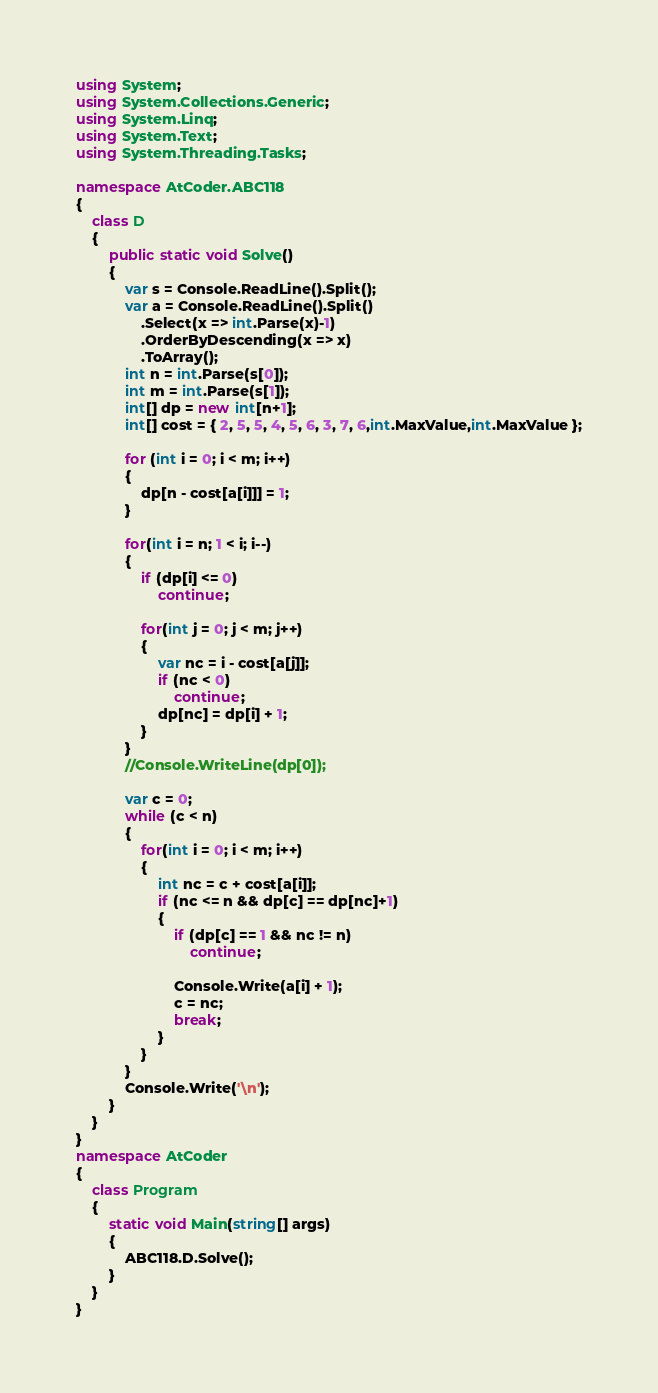<code> <loc_0><loc_0><loc_500><loc_500><_C#_>using System;
using System.Collections.Generic;
using System.Linq;
using System.Text;
using System.Threading.Tasks;

namespace AtCoder.ABC118
{
    class D
    {
        public static void Solve()
        {
            var s = Console.ReadLine().Split();
            var a = Console.ReadLine().Split()
                .Select(x => int.Parse(x)-1)
                .OrderByDescending(x => x)
                .ToArray();
            int n = int.Parse(s[0]);
            int m = int.Parse(s[1]);
            int[] dp = new int[n+1];
            int[] cost = { 2, 5, 5, 4, 5, 6, 3, 7, 6,int.MaxValue,int.MaxValue };

            for (int i = 0; i < m; i++)
            {
                dp[n - cost[a[i]]] = 1;
            }

            for(int i = n; 1 < i; i--)
            {
                if (dp[i] <= 0)
                    continue;

                for(int j = 0; j < m; j++)
                {
                    var nc = i - cost[a[j]];
                    if (nc < 0)
                        continue;
                    dp[nc] = dp[i] + 1;
                }
            }
            //Console.WriteLine(dp[0]);

            var c = 0;
            while (c < n)
            {
                for(int i = 0; i < m; i++)
                {
                    int nc = c + cost[a[i]];
                    if (nc <= n && dp[c] == dp[nc]+1)
                    {
                        if (dp[c] == 1 && nc != n)
                            continue;

                        Console.Write(a[i] + 1);
                        c = nc;
                        break;
                    }
                }
            }
            Console.Write('\n');
        }
    }
}
namespace AtCoder
{
    class Program
    {
        static void Main(string[] args)
        {
            ABC118.D.Solve();
        }
    }
}
</code> 